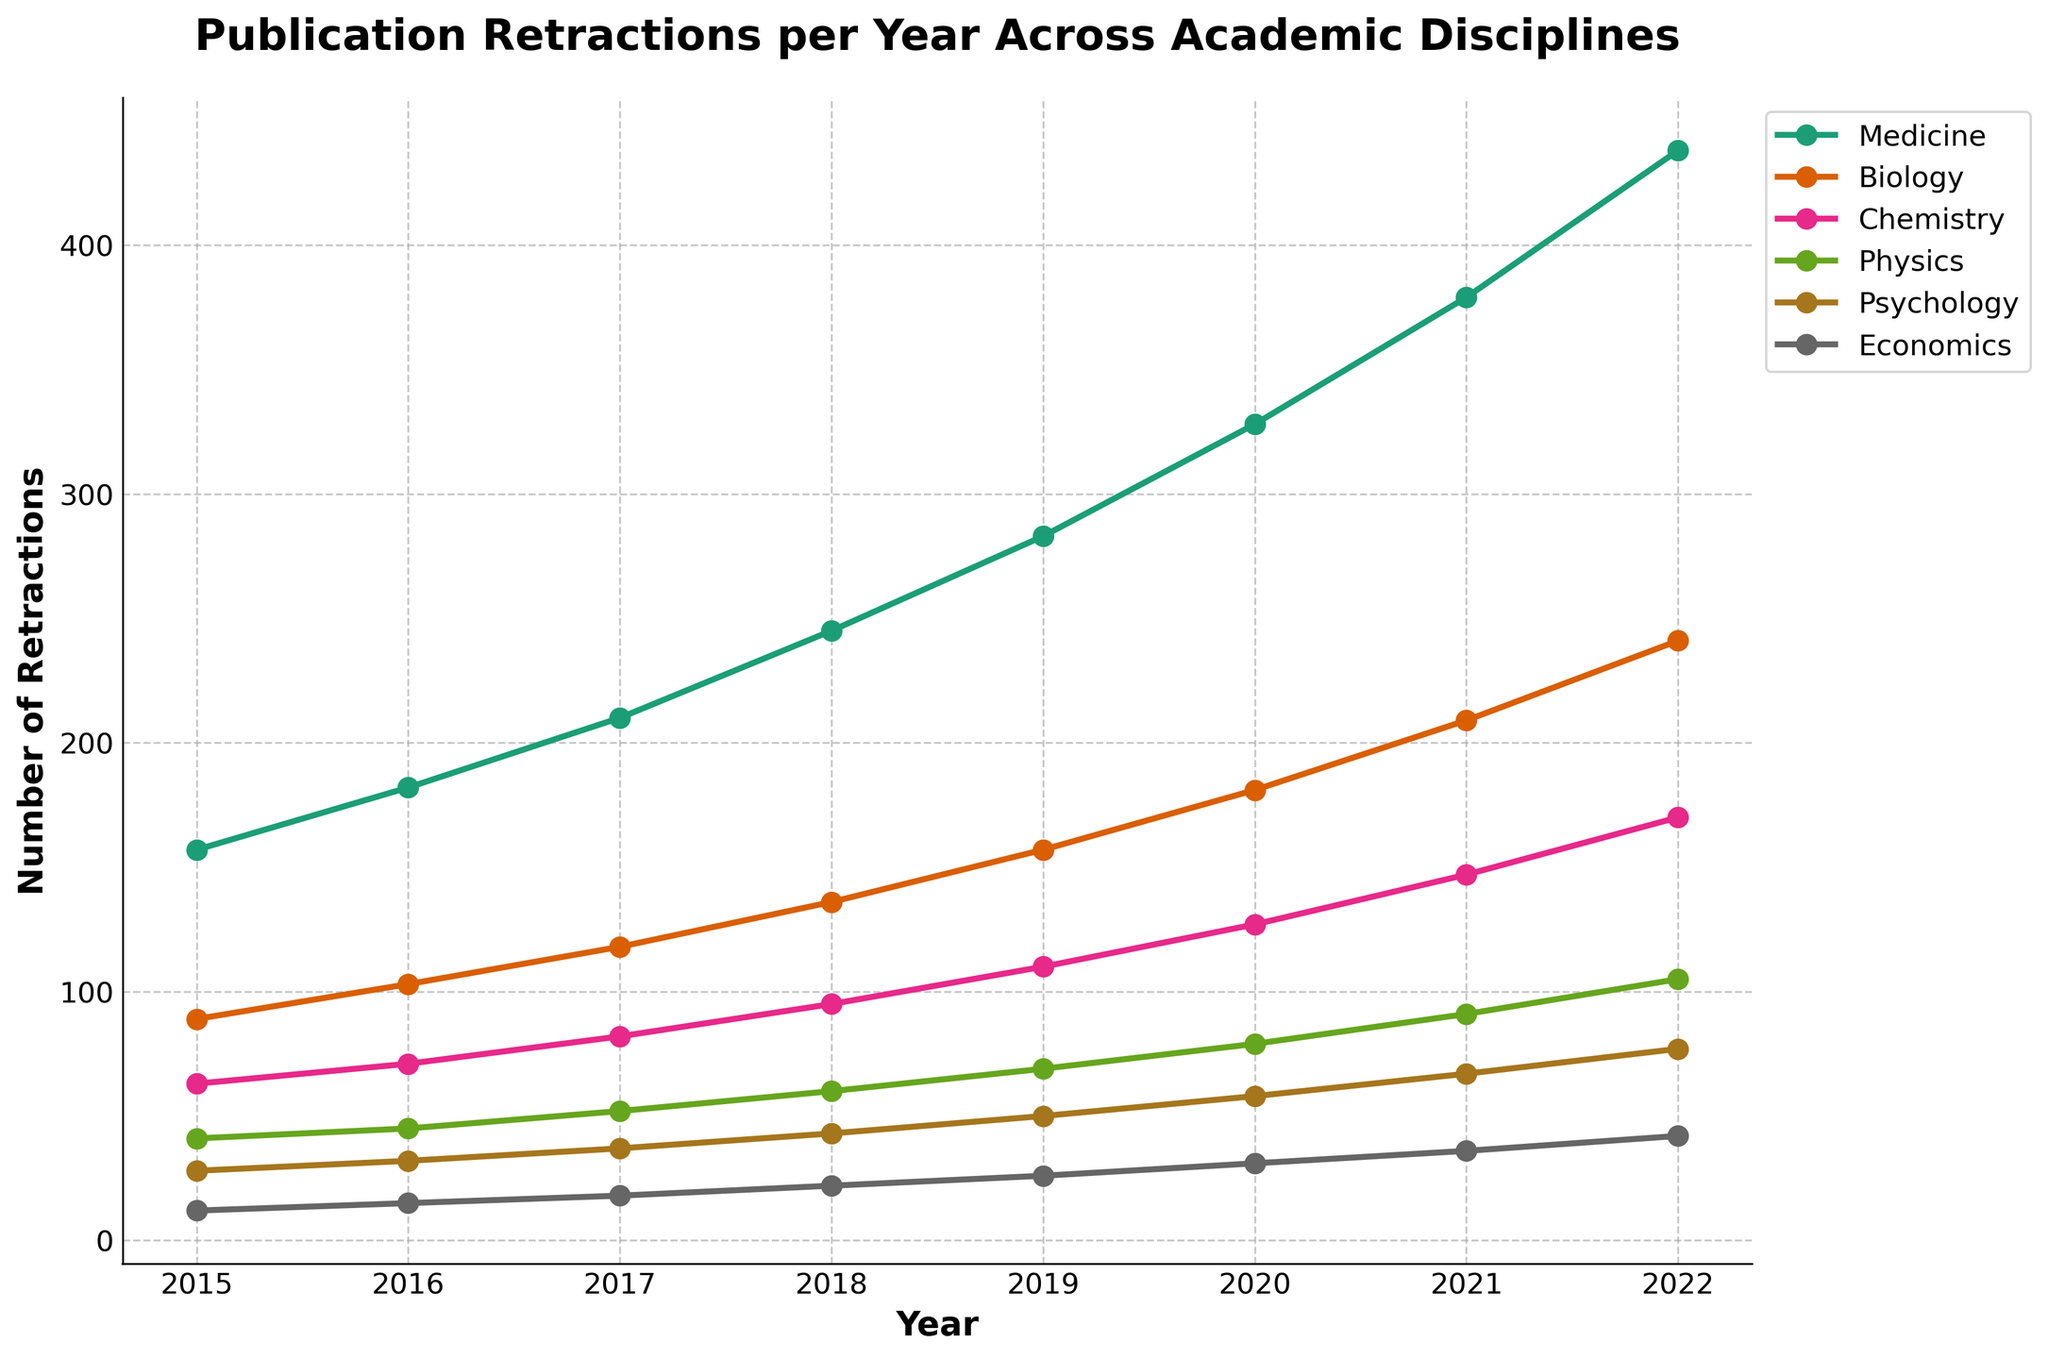what is the total number of retractions in Medicine over all years combined? Sum the number of retractions in Medicine from 2015 to 2022: 157 + 182 + 210 + 245 + 283 + 328 + 379 + 438 = 2222
Answer: 2222 Which academic discipline had the highest number of retractions in 2022? Look at the 2022 values for each discipline. Medicine had 438, Biology had 241, Chemistry had 170, Physics had 105, Psychology had 77, and Economics had 42. Medicine had the highest number.
Answer: Medicine What is the average number of annual retractions in Physics from 2015 to 2022? Sum the retractions in Physics from 2015 to 2022 and then divide by the number of years: (41 + 45 + 52 + 60 + 69 + 79 + 91 + 105) / 8 = 67.75
Answer: 67.75 Compare the number of retractions between Biology and Chemistry in 2020. Which one is higher and by how many? The retractions in Biology in 2020 were 181 and in Chemistry were 127. To find the difference: 181 - 127 = 54. So, Biology had 54 more retractions than Chemistry.
Answer: Biology by 54 